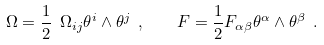Convert formula to latex. <formula><loc_0><loc_0><loc_500><loc_500>\Omega = \frac { 1 } { 2 } \ \Omega _ { i j } \theta ^ { i } \wedge \theta ^ { j } \ , \quad F = \frac { 1 } { 2 } F _ { \alpha \beta } \theta ^ { \alpha } \wedge \theta ^ { \beta } \ .</formula> 